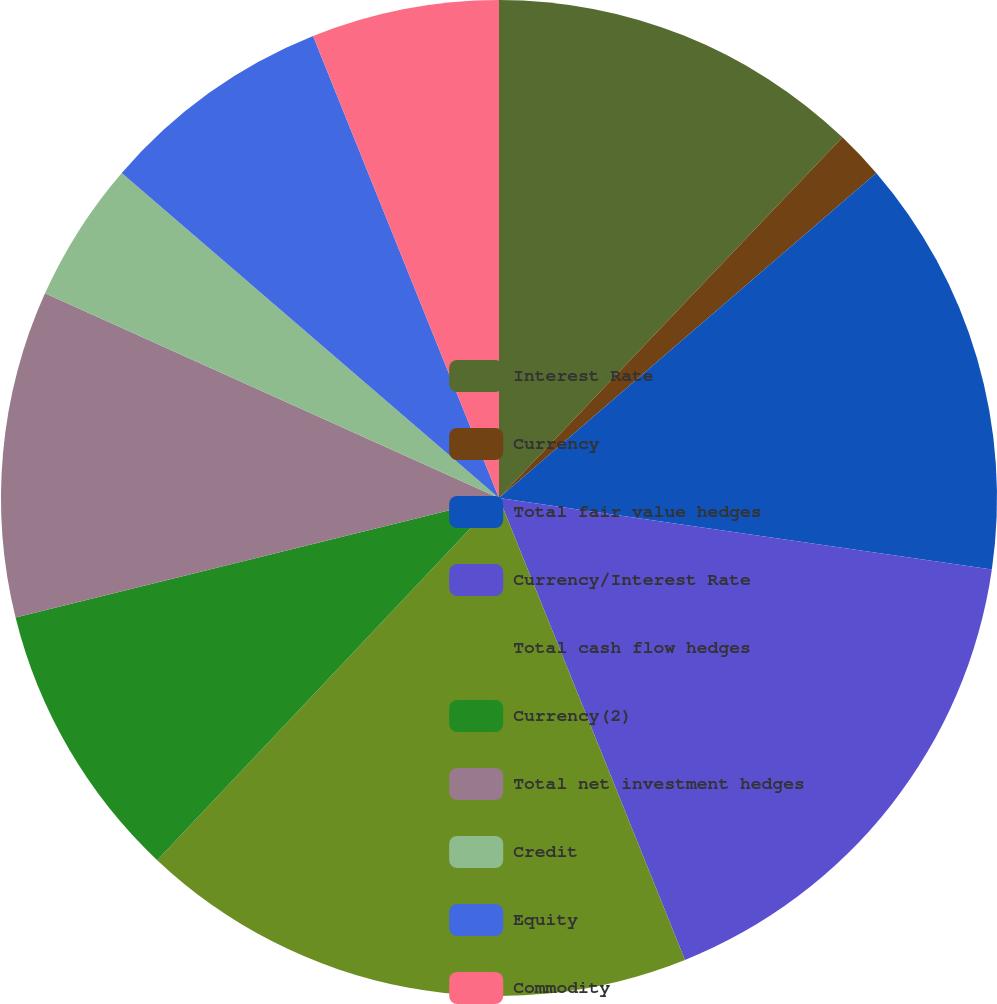Convert chart. <chart><loc_0><loc_0><loc_500><loc_500><pie_chart><fcel>Interest Rate<fcel>Currency<fcel>Total fair value hedges<fcel>Currency/Interest Rate<fcel>Total cash flow hedges<fcel>Currency(2)<fcel>Total net investment hedges<fcel>Credit<fcel>Equity<fcel>Commodity<nl><fcel>12.11%<fcel>1.57%<fcel>13.61%<fcel>16.62%<fcel>18.13%<fcel>9.1%<fcel>10.6%<fcel>4.58%<fcel>7.59%<fcel>6.09%<nl></chart> 